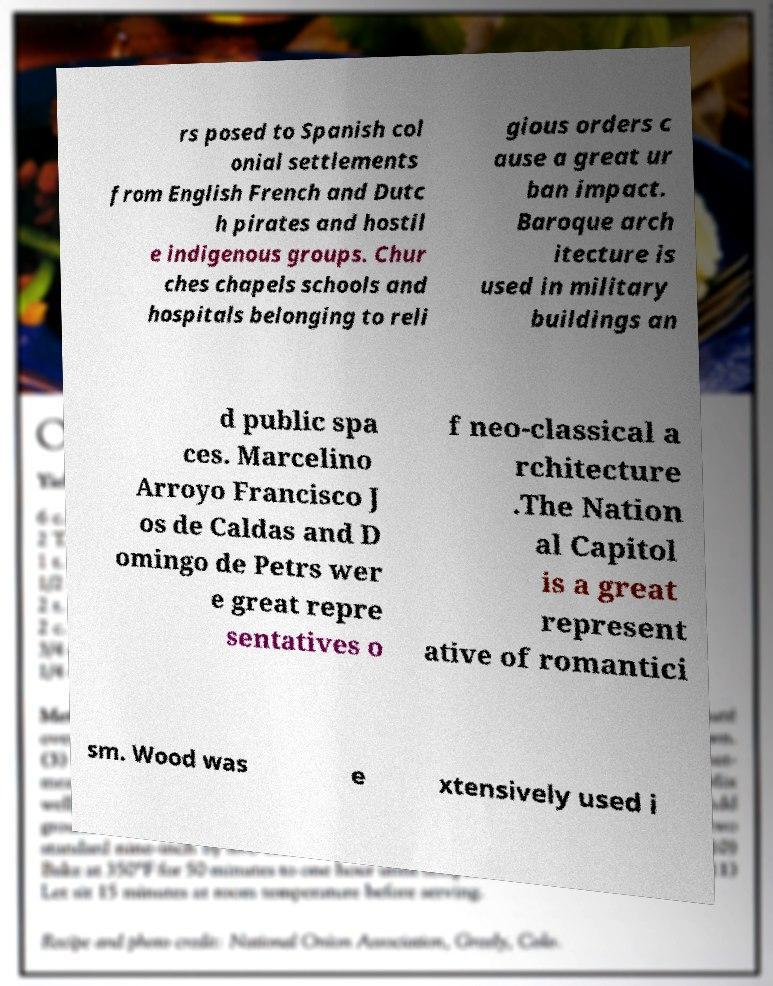Please identify and transcribe the text found in this image. rs posed to Spanish col onial settlements from English French and Dutc h pirates and hostil e indigenous groups. Chur ches chapels schools and hospitals belonging to reli gious orders c ause a great ur ban impact. Baroque arch itecture is used in military buildings an d public spa ces. Marcelino Arroyo Francisco J os de Caldas and D omingo de Petrs wer e great repre sentatives o f neo-classical a rchitecture .The Nation al Capitol is a great represent ative of romantici sm. Wood was e xtensively used i 